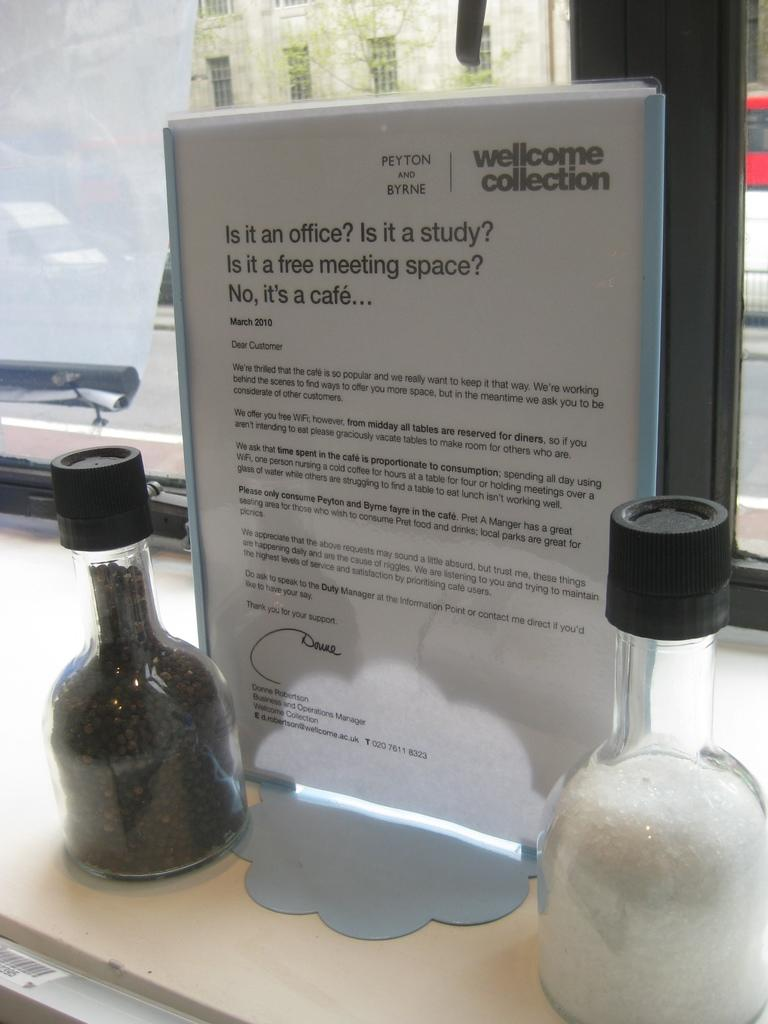<image>
Present a compact description of the photo's key features. some words in the top right corner saying welcome collection 